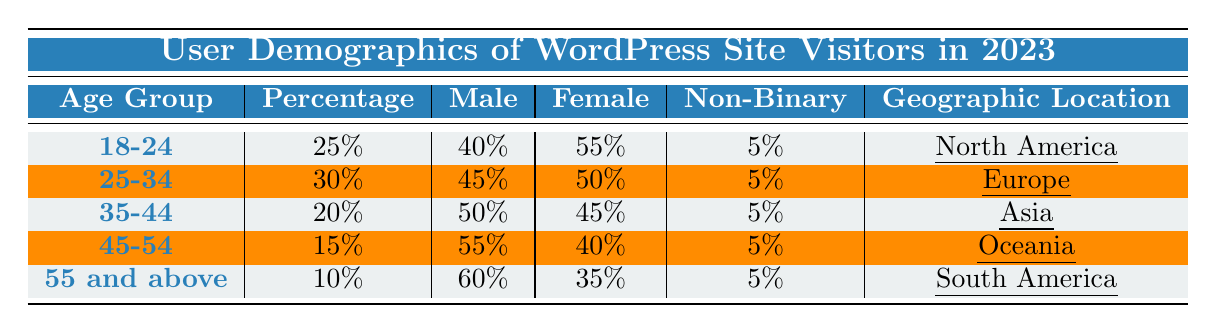What percentage of site visitors are aged 25-34? According to the table, the percentage of visitors in the age group 25-34 is explicitly listed as 30%.
Answer: 30% Which geographic location has the highest percentage of site visitors? By comparing the percentages listed next to each geographic location, North America has the highest percentage at 25%.
Answer: North America What is the total percentage of male visitors across all age groups? To find the total percentage, sum the male percentages: 40% + 45% + 50% + 55% + 60% = 250%.
Answer: 250% Is the percentage of female visitors in the age group 45-54 greater than that in the age group 35-44? The percentage for females in the 45-54 age group is 40% while in the 35-44 age group it is 45%. Thus, 40% is not greater than 45%.
Answer: No What is the average percentage of non-binary visitors across all age groups? The non-binary percentages are all the same in each age group at 5%. So the average is simply 5%.
Answer: 5% In which geographic location are the least amount of visitors aged 55 and above found? The table indicates that the geographic location for visitors aged 55 and above is South America, which contributes 10%. Since it is the only entry for this age group, it represents the least.
Answer: South America How does the gender distribution of the 18-24 age group compare to the 55 and above age group for males? For males in the 18-24 age group, the percentage is 40%, and for the 55 and above group, it is 60%. Thus, 60% (55 and above) is greater than 40% (18-24).
Answer: 60% is greater Which age group has the lowest percentage of site visitors? By examining the percentages listed, the age group 55 and above has the lowest percentage of 10%.
Answer: 55 and above If we consider only the age groups 25-34 and 35-44, what is the combined percentage of female visitors? The female visitors' percentages for these age groups are 50% (25-34) and 45% (35-44). The combined percentage is 50% + 45% = 95%.
Answer: 95% Is the percentage of visitors interested in blogging the same across all age groups? The interests for each age group indicate that only the 18-24 group lists "Blogging" as an interest while others have different focuses. Hence, it is not the same across all age groups.
Answer: No 